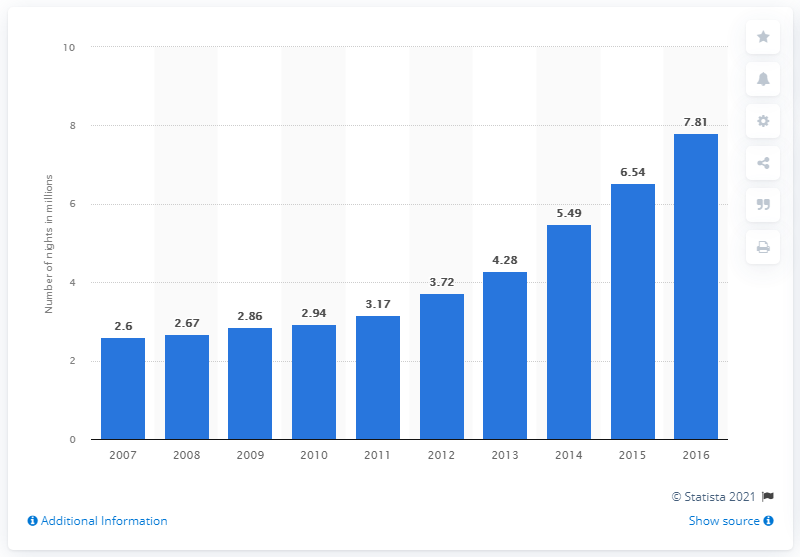Draw attention to some important aspects in this diagram. The median is a measure of central tendency that is used to describe the value that separates the higher half of a dataset from the lower half. In other words, it is the middle value of a dataset when it is ordered from smallest to largest. For example, if a dataset contains the numbers 1, 2, 3, 4, 5, and 6, the median would be 3. The maximum difference between years can be 5.21. Between 2007 and 2016, a total of 7.81 nights were spent at tourist accommodation establishments in Iceland. 